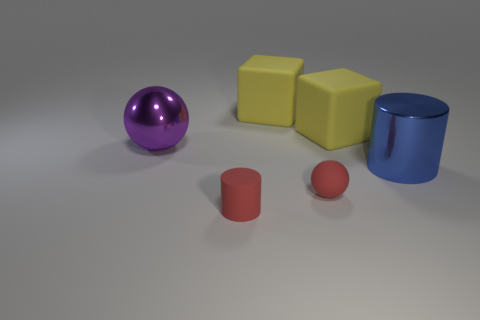How many things are balls or cylinders that are behind the tiny red matte cylinder?
Offer a very short reply. 3. Do the cylinder that is in front of the blue cylinder and the metal cylinder have the same size?
Keep it short and to the point. No. There is a sphere that is behind the shiny cylinder; what material is it?
Your answer should be very brief. Metal. Are there an equal number of objects that are on the left side of the purple shiny sphere and rubber blocks on the left side of the small matte ball?
Give a very brief answer. No. What is the color of the small rubber object that is the same shape as the big purple shiny thing?
Provide a short and direct response. Red. Are there any other things of the same color as the tiny ball?
Make the answer very short. Yes. How many matte things are either small purple objects or red objects?
Provide a succinct answer. 2. Does the small sphere have the same color as the matte cylinder?
Offer a terse response. Yes. Are there more balls in front of the large purple shiny sphere than tiny yellow rubber cubes?
Keep it short and to the point. Yes. What number of other objects are the same material as the tiny red cylinder?
Ensure brevity in your answer.  3. 